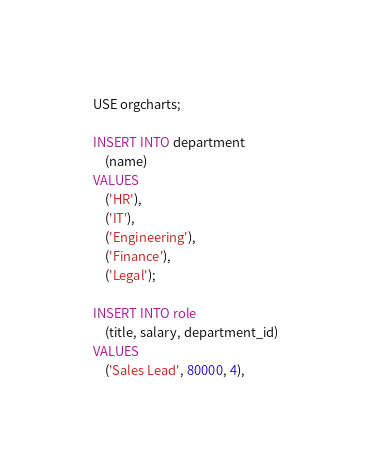Convert code to text. <code><loc_0><loc_0><loc_500><loc_500><_SQL_>USE orgcharts;

INSERT INTO department
    (name)
VALUES
    ('HR'),
    ('IT'),
    ('Engineering'),
    ('Finance'),
    ('Legal');

INSERT INTO role
    (title, salary, department_id)
VALUES
    ('Sales Lead', 80000, 4),</code> 